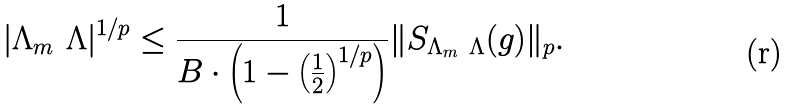Convert formula to latex. <formula><loc_0><loc_0><loc_500><loc_500>| \Lambda _ { m } \ \Lambda | ^ { 1 / p } \leq \frac { 1 } { B \cdot \left ( 1 - \left ( \frac { 1 } { 2 } \right ) ^ { 1 / p } \right ) } \| S _ { \Lambda _ { m } \ \Lambda } ( g ) \| _ { p } .</formula> 